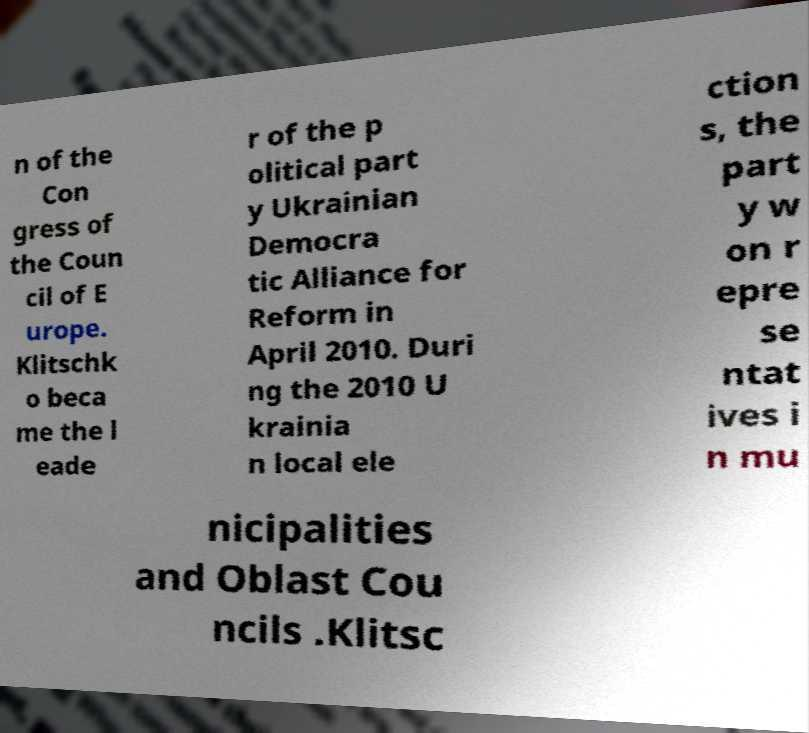Could you extract and type out the text from this image? n of the Con gress of the Coun cil of E urope. Klitschk o beca me the l eade r of the p olitical part y Ukrainian Democra tic Alliance for Reform in April 2010. Duri ng the 2010 U krainia n local ele ction s, the part y w on r epre se ntat ives i n mu nicipalities and Oblast Cou ncils .Klitsc 